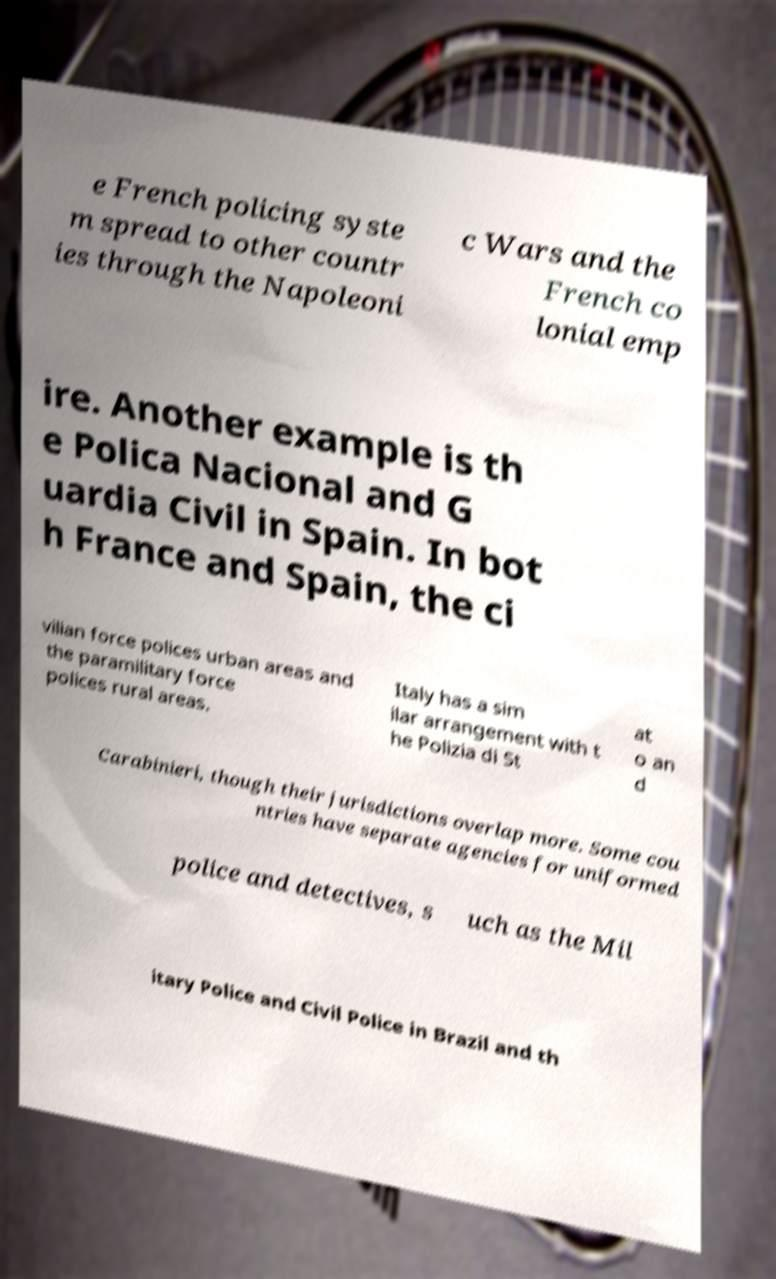Please read and relay the text visible in this image. What does it say? e French policing syste m spread to other countr ies through the Napoleoni c Wars and the French co lonial emp ire. Another example is th e Polica Nacional and G uardia Civil in Spain. In bot h France and Spain, the ci vilian force polices urban areas and the paramilitary force polices rural areas. Italy has a sim ilar arrangement with t he Polizia di St at o an d Carabinieri, though their jurisdictions overlap more. Some cou ntries have separate agencies for uniformed police and detectives, s uch as the Mil itary Police and Civil Police in Brazil and th 